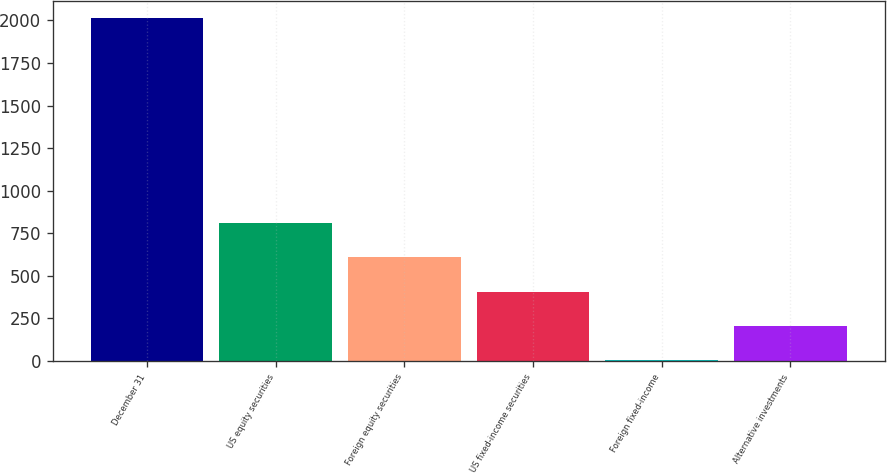Convert chart. <chart><loc_0><loc_0><loc_500><loc_500><bar_chart><fcel>December 31<fcel>US equity securities<fcel>Foreign equity securities<fcel>US fixed-income securities<fcel>Foreign fixed-income<fcel>Alternative investments<nl><fcel>2016<fcel>808.8<fcel>607.6<fcel>406.4<fcel>4<fcel>205.2<nl></chart> 